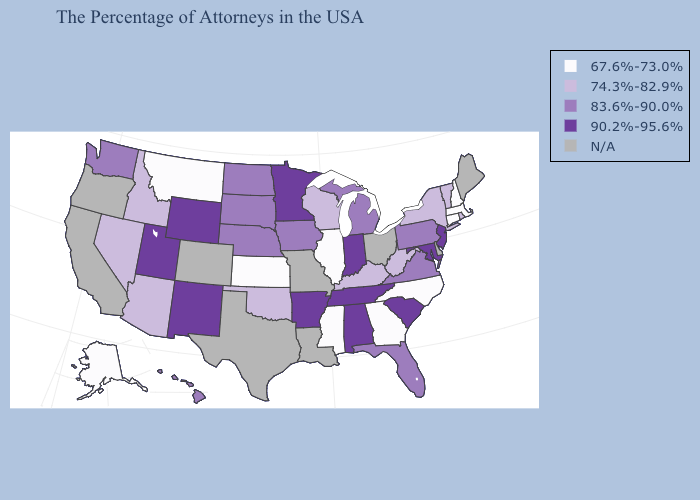Name the states that have a value in the range 67.6%-73.0%?
Short answer required. Massachusetts, New Hampshire, Connecticut, North Carolina, Georgia, Illinois, Mississippi, Kansas, Montana, Alaska. Does West Virginia have the highest value in the USA?
Short answer required. No. Name the states that have a value in the range 83.6%-90.0%?
Answer briefly. Pennsylvania, Virginia, Florida, Michigan, Iowa, Nebraska, South Dakota, North Dakota, Washington, Hawaii. Does the first symbol in the legend represent the smallest category?
Short answer required. Yes. What is the value of Virginia?
Keep it brief. 83.6%-90.0%. Among the states that border Tennessee , which have the highest value?
Keep it brief. Alabama, Arkansas. What is the value of Washington?
Quick response, please. 83.6%-90.0%. Name the states that have a value in the range N/A?
Answer briefly. Maine, Delaware, Ohio, Louisiana, Missouri, Texas, Colorado, California, Oregon. Name the states that have a value in the range 74.3%-82.9%?
Keep it brief. Rhode Island, Vermont, New York, West Virginia, Kentucky, Wisconsin, Oklahoma, Arizona, Idaho, Nevada. What is the value of Maine?
Concise answer only. N/A. What is the value of New Hampshire?
Quick response, please. 67.6%-73.0%. What is the value of North Dakota?
Short answer required. 83.6%-90.0%. Name the states that have a value in the range 67.6%-73.0%?
Quick response, please. Massachusetts, New Hampshire, Connecticut, North Carolina, Georgia, Illinois, Mississippi, Kansas, Montana, Alaska. What is the highest value in the West ?
Give a very brief answer. 90.2%-95.6%. 